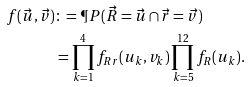<formula> <loc_0><loc_0><loc_500><loc_500>f ( \vec { u } , \vec { v } ) & \colon = \P P ( \vec { R } = \vec { u } \cap \vec { r } = \vec { v } ) \\ & = \prod _ { k = 1 } ^ { 4 } f _ { R r } ( u _ { k } , v _ { k } ) \prod _ { k = 5 } ^ { 1 2 } f _ { R } ( u _ { k } ) .</formula> 